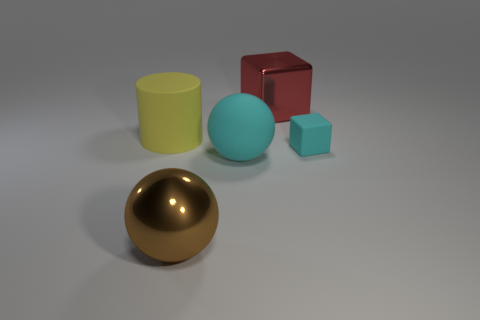Are there any yellow rubber cylinders behind the tiny cube? Yes, there is one yellow rubber cylinder positioned behind the small, light blue cube. 